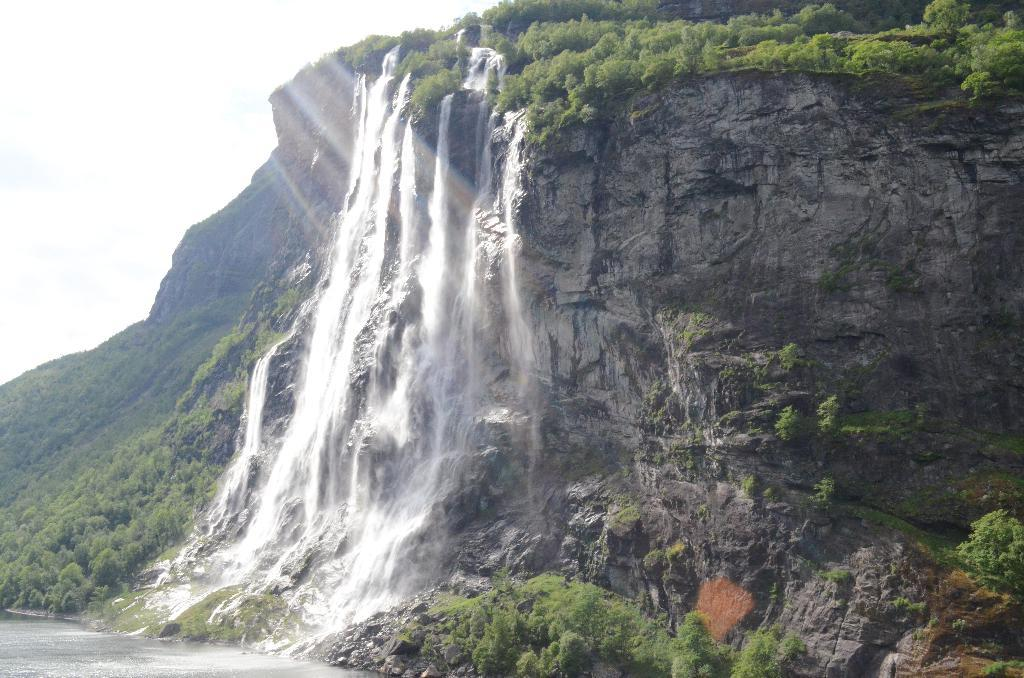What is happening in the image? There is water flowing in the image. Where is the water coming from? The water is flowing from a hill. What can be seen on the hill? There are trees on the hill. What is visible on the left side of the image? The sky is visible on the left side of the image. How many beans are scattered on the hill in the image? There are no beans present in the image; it features water flowing from a hill with trees. Is there a tent visible on the hill in the image? There is no tent present in the image; it only shows water flowing from a hill with trees. 